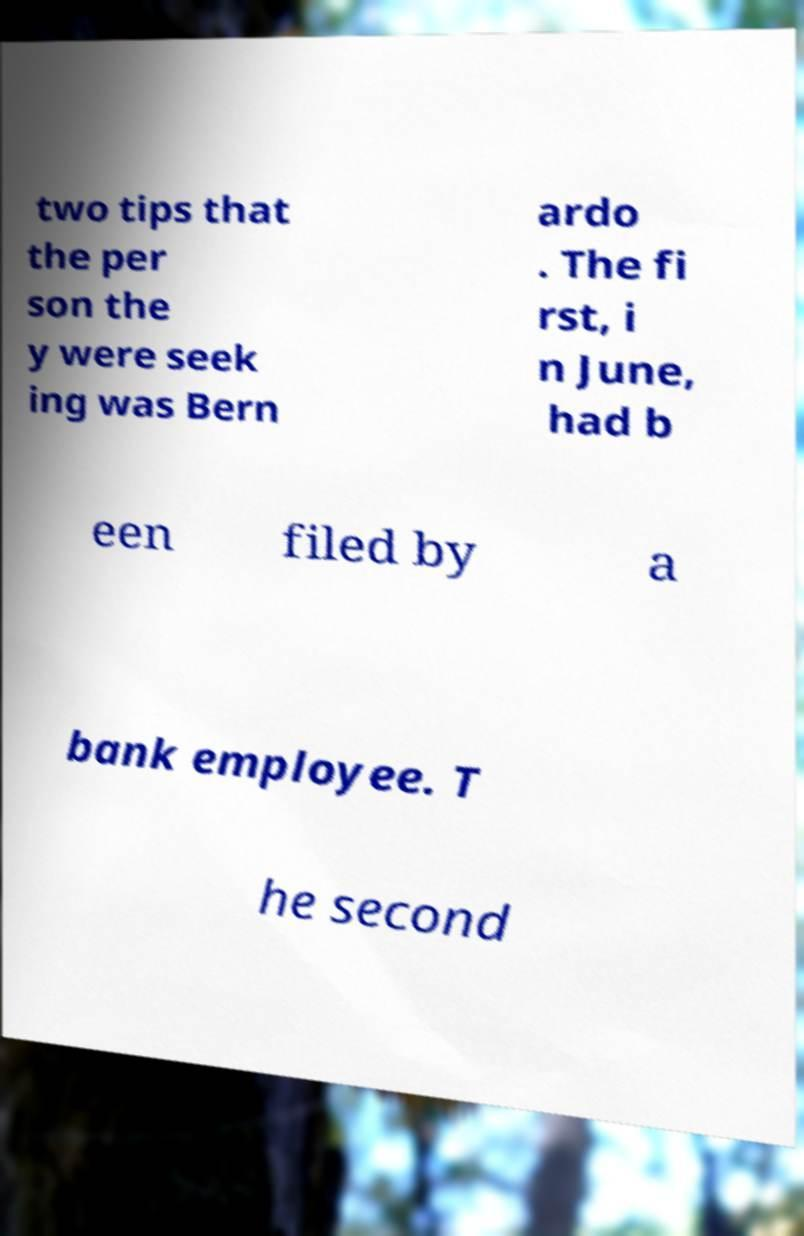Could you extract and type out the text from this image? two tips that the per son the y were seek ing was Bern ardo . The fi rst, i n June, had b een filed by a bank employee. T he second 